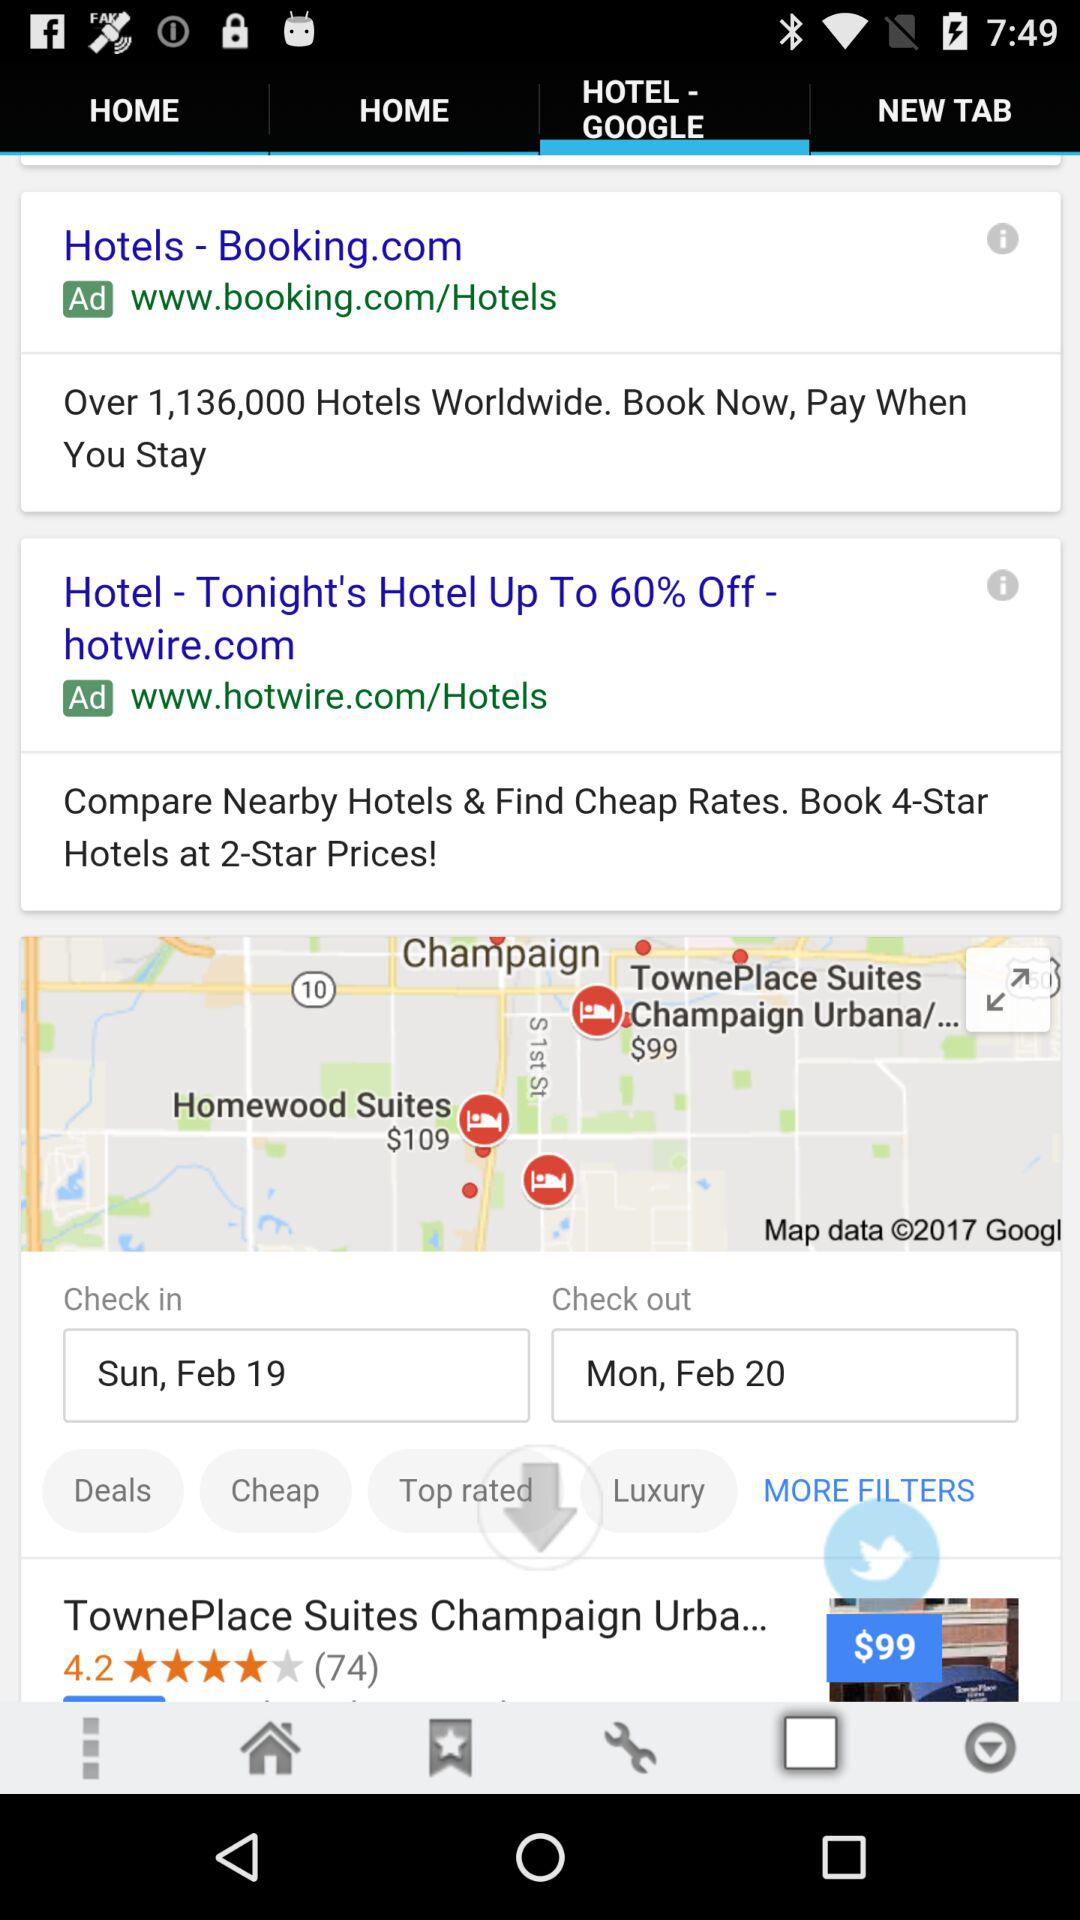What is the check-in date? The check-in date is Sunday, February 19. 